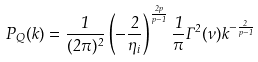Convert formula to latex. <formula><loc_0><loc_0><loc_500><loc_500>P _ { Q } ( k ) = \frac { 1 } { ( 2 \pi ) ^ { 2 } } \left ( - \frac { 2 } { \eta _ { i } } \right ) ^ { \frac { 2 p } { p - 1 } } \frac { 1 } { \pi } \Gamma ^ { 2 } ( \nu ) k ^ { - \frac { 2 } { p - 1 } }</formula> 